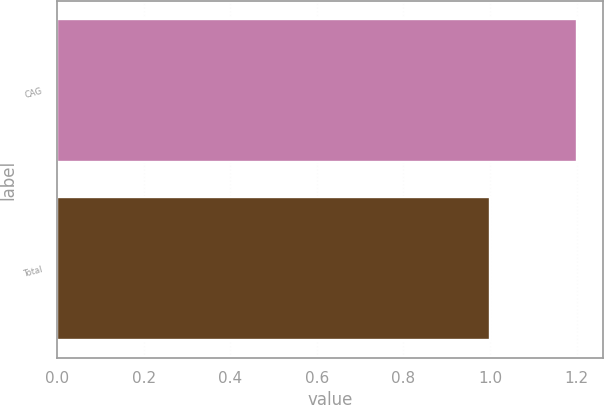<chart> <loc_0><loc_0><loc_500><loc_500><bar_chart><fcel>CAG<fcel>Total<nl><fcel>1.2<fcel>1<nl></chart> 